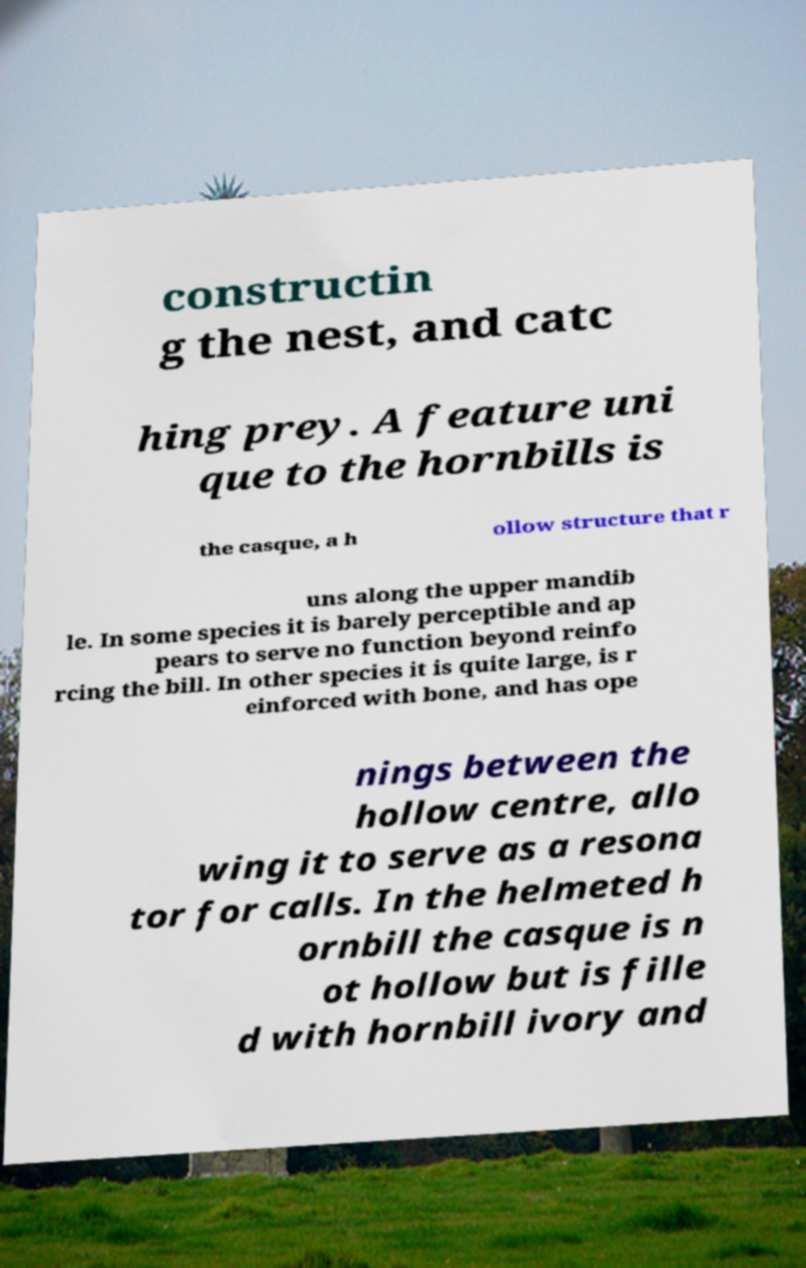Could you assist in decoding the text presented in this image and type it out clearly? constructin g the nest, and catc hing prey. A feature uni que to the hornbills is the casque, a h ollow structure that r uns along the upper mandib le. In some species it is barely perceptible and ap pears to serve no function beyond reinfo rcing the bill. In other species it is quite large, is r einforced with bone, and has ope nings between the hollow centre, allo wing it to serve as a resona tor for calls. In the helmeted h ornbill the casque is n ot hollow but is fille d with hornbill ivory and 